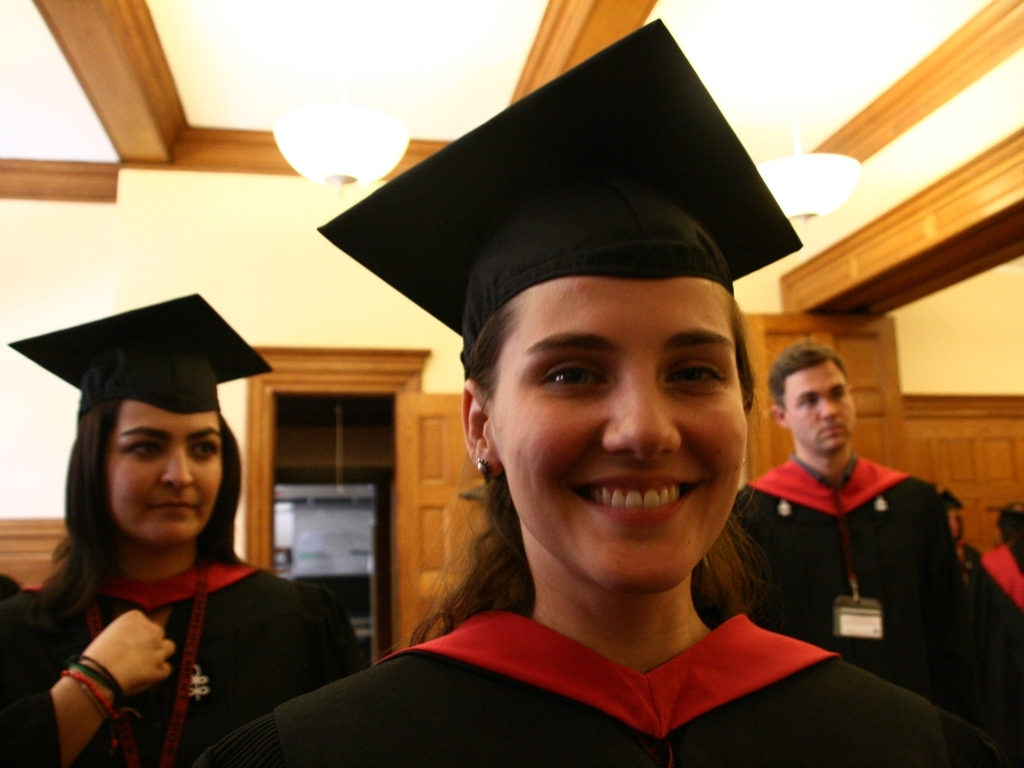What is the occasion being captured in this image? This image appears to capture a graduation ceremony, indicated by the academic attire commonly known as cap and gown, worn by the individuals. These events mark the completion of a degree program and are significant milestones for students. 